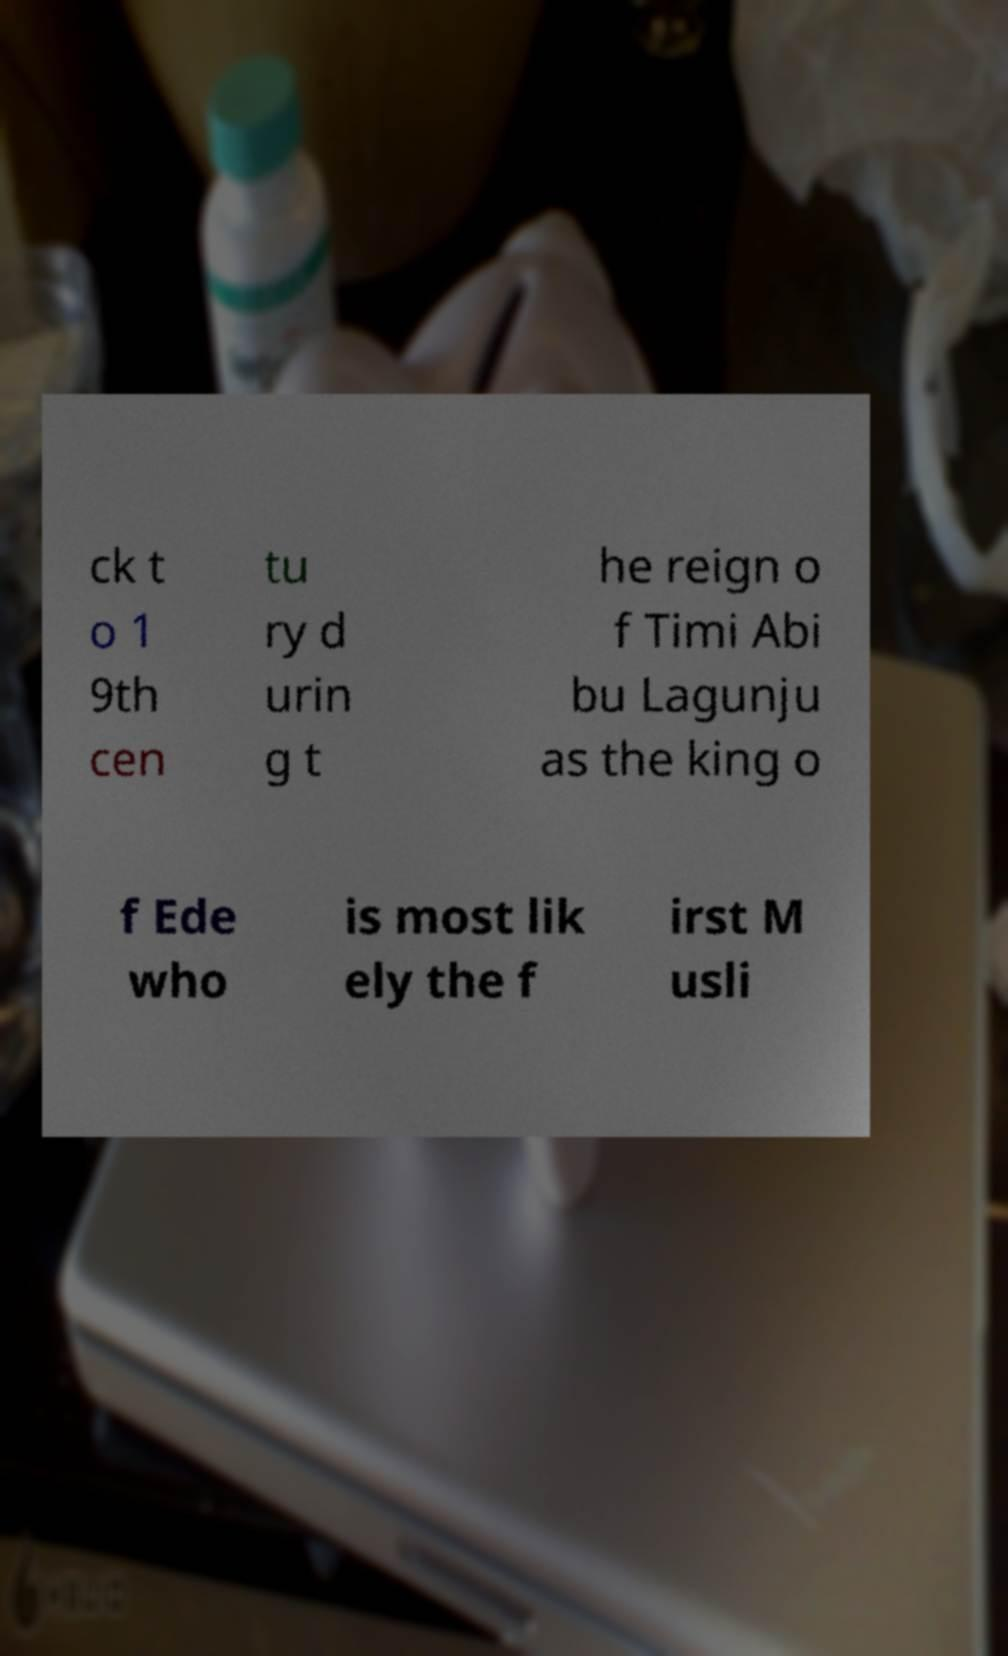Can you accurately transcribe the text from the provided image for me? ck t o 1 9th cen tu ry d urin g t he reign o f Timi Abi bu Lagunju as the king o f Ede who is most lik ely the f irst M usli 